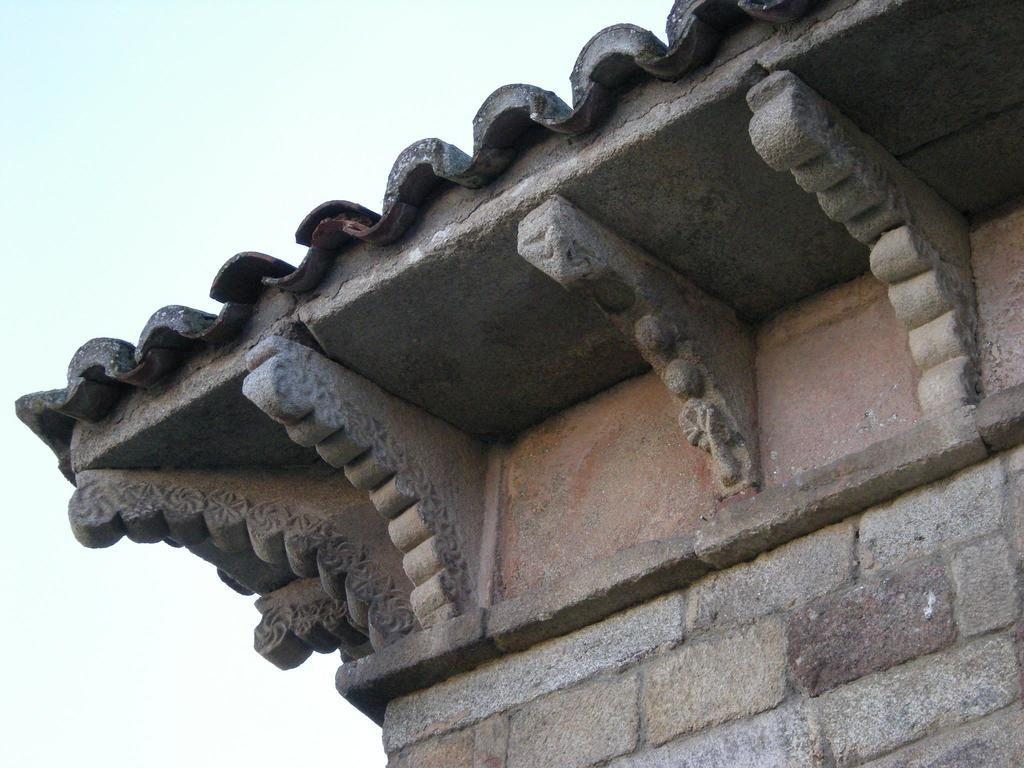What structure is located on the right side of the image? There is a building on the right side of the image. What feature of the building can be seen in the image? The building has a roof. What is present on the roof of the building? There is a sculpture on the roof of the building. How many cherries are on the rose in the image? There is no rose or cherries present in the image. Can you describe the kiss between the two people in the image? There are no people or kisses depicted in the image; it features a building with a sculpture on the roof. 